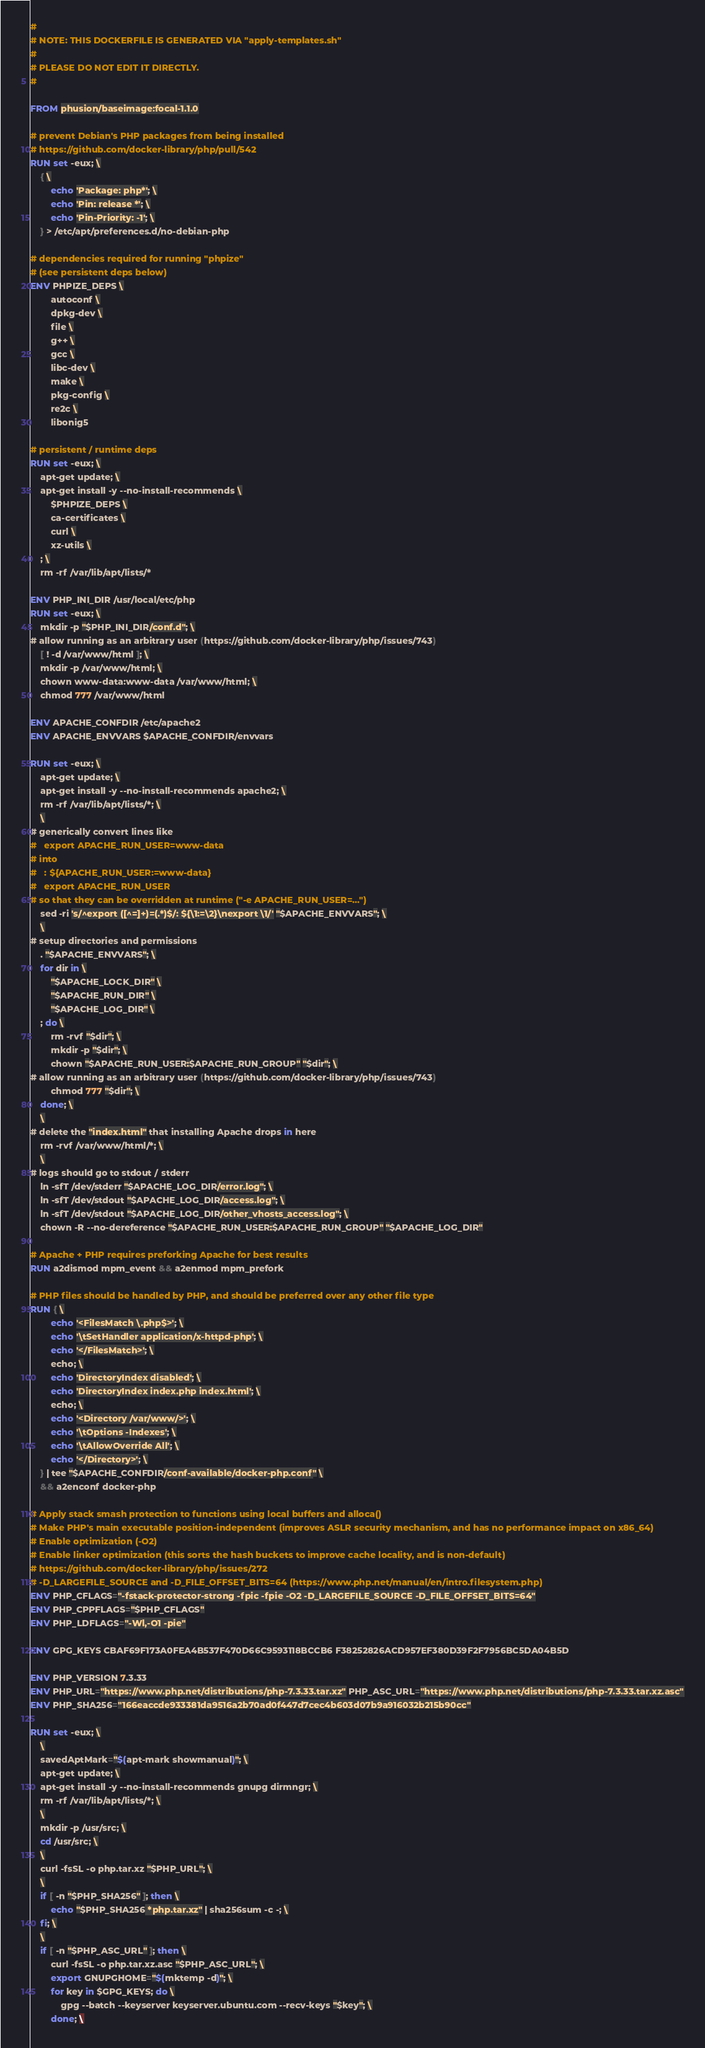Convert code to text. <code><loc_0><loc_0><loc_500><loc_500><_Dockerfile_>#
# NOTE: THIS DOCKERFILE IS GENERATED VIA "apply-templates.sh"
#
# PLEASE DO NOT EDIT IT DIRECTLY.
#

FROM phusion/baseimage:focal-1.1.0

# prevent Debian's PHP packages from being installed
# https://github.com/docker-library/php/pull/542
RUN set -eux; \
	{ \
		echo 'Package: php*'; \
		echo 'Pin: release *'; \
		echo 'Pin-Priority: -1'; \
	} > /etc/apt/preferences.d/no-debian-php

# dependencies required for running "phpize"
# (see persistent deps below)
ENV PHPIZE_DEPS \
		autoconf \
		dpkg-dev \
		file \
		g++ \
		gcc \
		libc-dev \
		make \
		pkg-config \
		re2c \
		libonig5

# persistent / runtime deps
RUN set -eux; \
	apt-get update; \
	apt-get install -y --no-install-recommends \
		$PHPIZE_DEPS \
		ca-certificates \
		curl \
		xz-utils \
	; \
	rm -rf /var/lib/apt/lists/*

ENV PHP_INI_DIR /usr/local/etc/php
RUN set -eux; \
	mkdir -p "$PHP_INI_DIR/conf.d"; \
# allow running as an arbitrary user (https://github.com/docker-library/php/issues/743)
	[ ! -d /var/www/html ]; \
	mkdir -p /var/www/html; \
	chown www-data:www-data /var/www/html; \
	chmod 777 /var/www/html

ENV APACHE_CONFDIR /etc/apache2
ENV APACHE_ENVVARS $APACHE_CONFDIR/envvars

RUN set -eux; \
	apt-get update; \
	apt-get install -y --no-install-recommends apache2; \
	rm -rf /var/lib/apt/lists/*; \
	\
# generically convert lines like
#   export APACHE_RUN_USER=www-data
# into
#   : ${APACHE_RUN_USER:=www-data}
#   export APACHE_RUN_USER
# so that they can be overridden at runtime ("-e APACHE_RUN_USER=...")
	sed -ri 's/^export ([^=]+)=(.*)$/: ${\1:=\2}\nexport \1/' "$APACHE_ENVVARS"; \
	\
# setup directories and permissions
	. "$APACHE_ENVVARS"; \
	for dir in \
		"$APACHE_LOCK_DIR" \
		"$APACHE_RUN_DIR" \
		"$APACHE_LOG_DIR" \
	; do \
		rm -rvf "$dir"; \
		mkdir -p "$dir"; \
		chown "$APACHE_RUN_USER:$APACHE_RUN_GROUP" "$dir"; \
# allow running as an arbitrary user (https://github.com/docker-library/php/issues/743)
		chmod 777 "$dir"; \
	done; \
	\
# delete the "index.html" that installing Apache drops in here
	rm -rvf /var/www/html/*; \
	\
# logs should go to stdout / stderr
	ln -sfT /dev/stderr "$APACHE_LOG_DIR/error.log"; \
	ln -sfT /dev/stdout "$APACHE_LOG_DIR/access.log"; \
	ln -sfT /dev/stdout "$APACHE_LOG_DIR/other_vhosts_access.log"; \
	chown -R --no-dereference "$APACHE_RUN_USER:$APACHE_RUN_GROUP" "$APACHE_LOG_DIR"

# Apache + PHP requires preforking Apache for best results
RUN a2dismod mpm_event && a2enmod mpm_prefork

# PHP files should be handled by PHP, and should be preferred over any other file type
RUN { \
		echo '<FilesMatch \.php$>'; \
		echo '\tSetHandler application/x-httpd-php'; \
		echo '</FilesMatch>'; \
		echo; \
		echo 'DirectoryIndex disabled'; \
		echo 'DirectoryIndex index.php index.html'; \
		echo; \
		echo '<Directory /var/www/>'; \
		echo '\tOptions -Indexes'; \
		echo '\tAllowOverride All'; \
		echo '</Directory>'; \
	} | tee "$APACHE_CONFDIR/conf-available/docker-php.conf" \
	&& a2enconf docker-php

# Apply stack smash protection to functions using local buffers and alloca()
# Make PHP's main executable position-independent (improves ASLR security mechanism, and has no performance impact on x86_64)
# Enable optimization (-O2)
# Enable linker optimization (this sorts the hash buckets to improve cache locality, and is non-default)
# https://github.com/docker-library/php/issues/272
# -D_LARGEFILE_SOURCE and -D_FILE_OFFSET_BITS=64 (https://www.php.net/manual/en/intro.filesystem.php)
ENV PHP_CFLAGS="-fstack-protector-strong -fpic -fpie -O2 -D_LARGEFILE_SOURCE -D_FILE_OFFSET_BITS=64"
ENV PHP_CPPFLAGS="$PHP_CFLAGS"
ENV PHP_LDFLAGS="-Wl,-O1 -pie"

ENV GPG_KEYS CBAF69F173A0FEA4B537F470D66C9593118BCCB6 F38252826ACD957EF380D39F2F7956BC5DA04B5D

ENV PHP_VERSION 7.3.33
ENV PHP_URL="https://www.php.net/distributions/php-7.3.33.tar.xz" PHP_ASC_URL="https://www.php.net/distributions/php-7.3.33.tar.xz.asc"
ENV PHP_SHA256="166eaccde933381da9516a2b70ad0f447d7cec4b603d07b9a916032b215b90cc"

RUN set -eux; \
	\
	savedAptMark="$(apt-mark showmanual)"; \
	apt-get update; \
	apt-get install -y --no-install-recommends gnupg dirmngr; \
	rm -rf /var/lib/apt/lists/*; \
	\
	mkdir -p /usr/src; \
	cd /usr/src; \
	\
	curl -fsSL -o php.tar.xz "$PHP_URL"; \
	\
	if [ -n "$PHP_SHA256" ]; then \
		echo "$PHP_SHA256 *php.tar.xz" | sha256sum -c -; \
	fi; \
	\
	if [ -n "$PHP_ASC_URL" ]; then \
		curl -fsSL -o php.tar.xz.asc "$PHP_ASC_URL"; \
		export GNUPGHOME="$(mktemp -d)"; \
		for key in $GPG_KEYS; do \
			gpg --batch --keyserver keyserver.ubuntu.com --recv-keys "$key"; \
		done; \</code> 